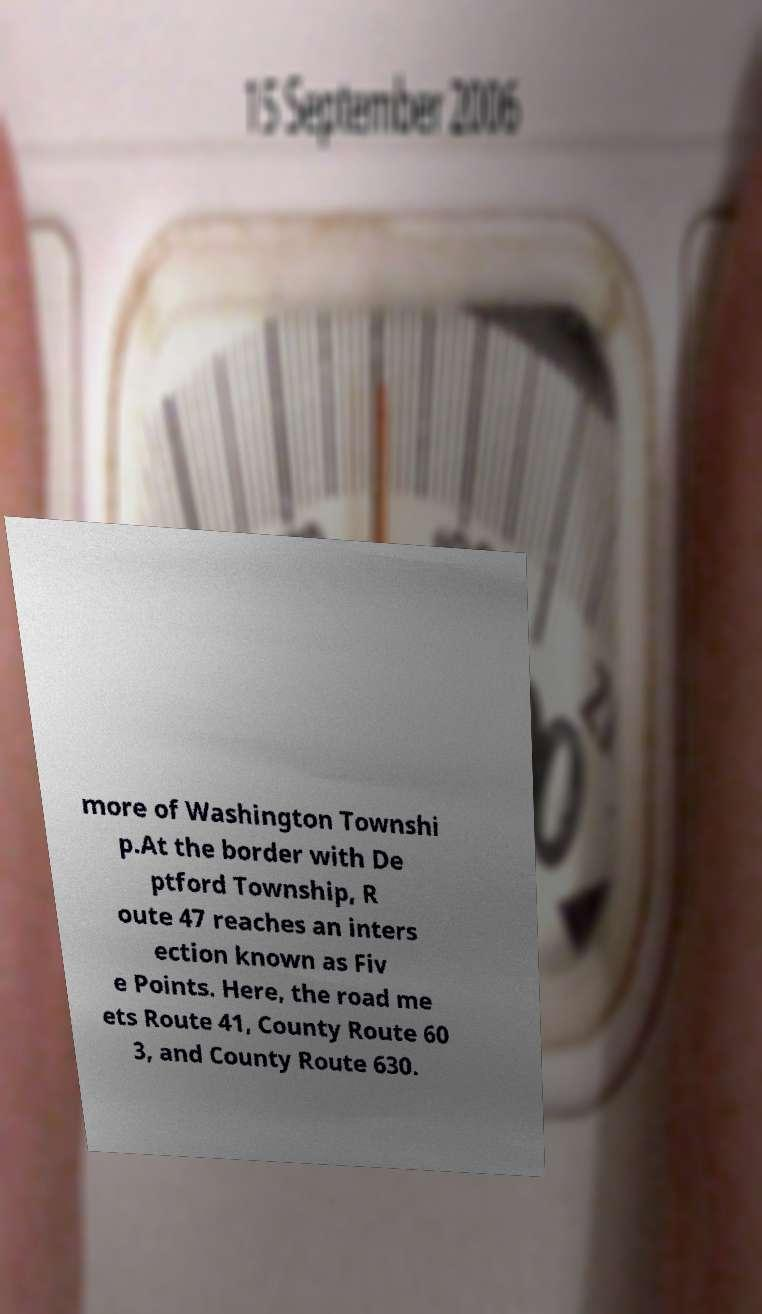Could you assist in decoding the text presented in this image and type it out clearly? more of Washington Townshi p.At the border with De ptford Township, R oute 47 reaches an inters ection known as Fiv e Points. Here, the road me ets Route 41, County Route 60 3, and County Route 630. 